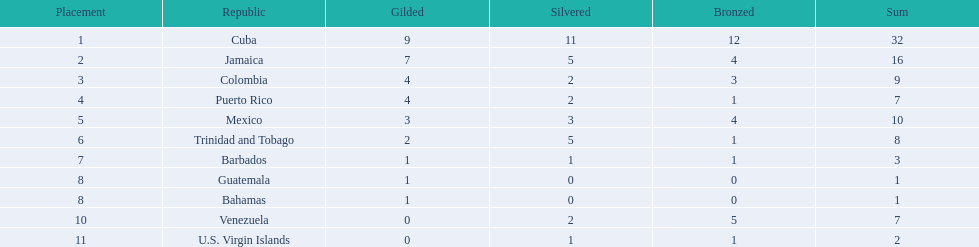What teams had four gold medals? Colombia, Puerto Rico. Of these two, which team only had one bronze medal? Puerto Rico. 